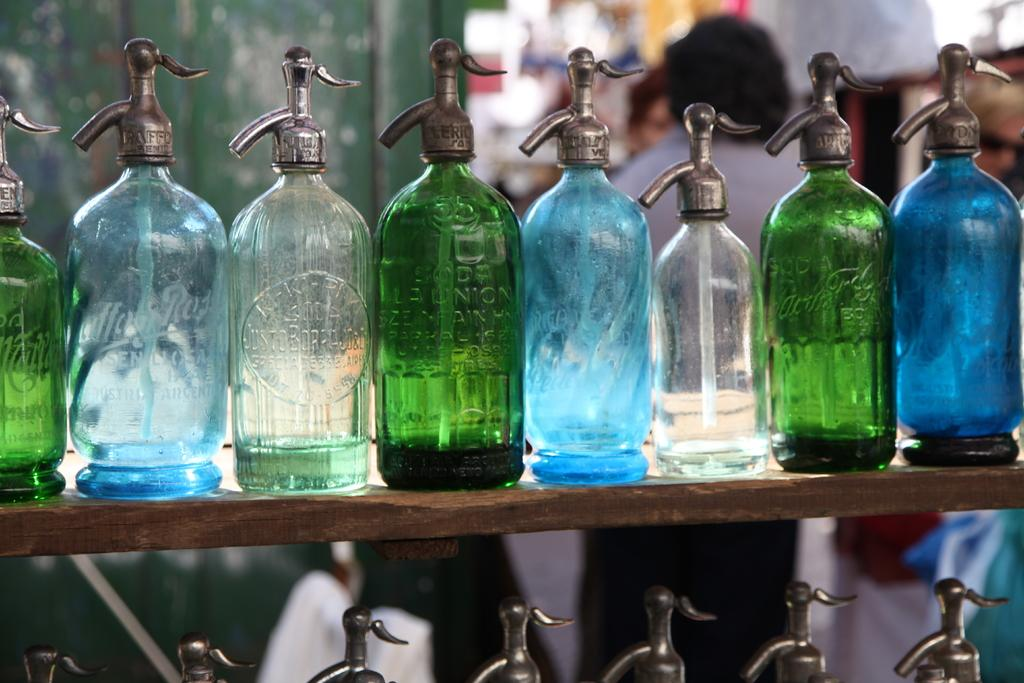What can be seen in large quantities in the image? There are many bottles in the image. What colors are the bottles? The bottles are blue and green in color. Is there anyone present in the image? Yes, there is a person in the image. What type of barrier can be seen in the image? There is a wooden fence in the image. What type of force is being applied to the bottles in the image? There is no indication of any force being applied to the bottles in the image. 